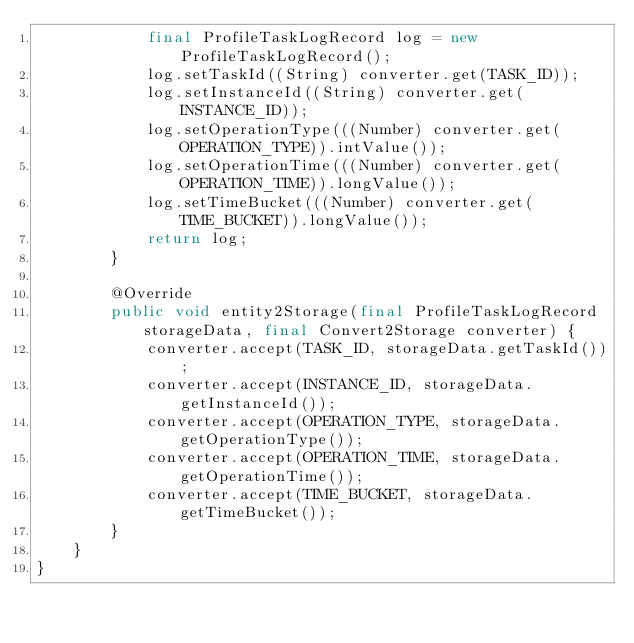Convert code to text. <code><loc_0><loc_0><loc_500><loc_500><_Java_>            final ProfileTaskLogRecord log = new ProfileTaskLogRecord();
            log.setTaskId((String) converter.get(TASK_ID));
            log.setInstanceId((String) converter.get(INSTANCE_ID));
            log.setOperationType(((Number) converter.get(OPERATION_TYPE)).intValue());
            log.setOperationTime(((Number) converter.get(OPERATION_TIME)).longValue());
            log.setTimeBucket(((Number) converter.get(TIME_BUCKET)).longValue());
            return log;
        }

        @Override
        public void entity2Storage(final ProfileTaskLogRecord storageData, final Convert2Storage converter) {
            converter.accept(TASK_ID, storageData.getTaskId());
            converter.accept(INSTANCE_ID, storageData.getInstanceId());
            converter.accept(OPERATION_TYPE, storageData.getOperationType());
            converter.accept(OPERATION_TIME, storageData.getOperationTime());
            converter.accept(TIME_BUCKET, storageData.getTimeBucket());
        }
    }
}
</code> 